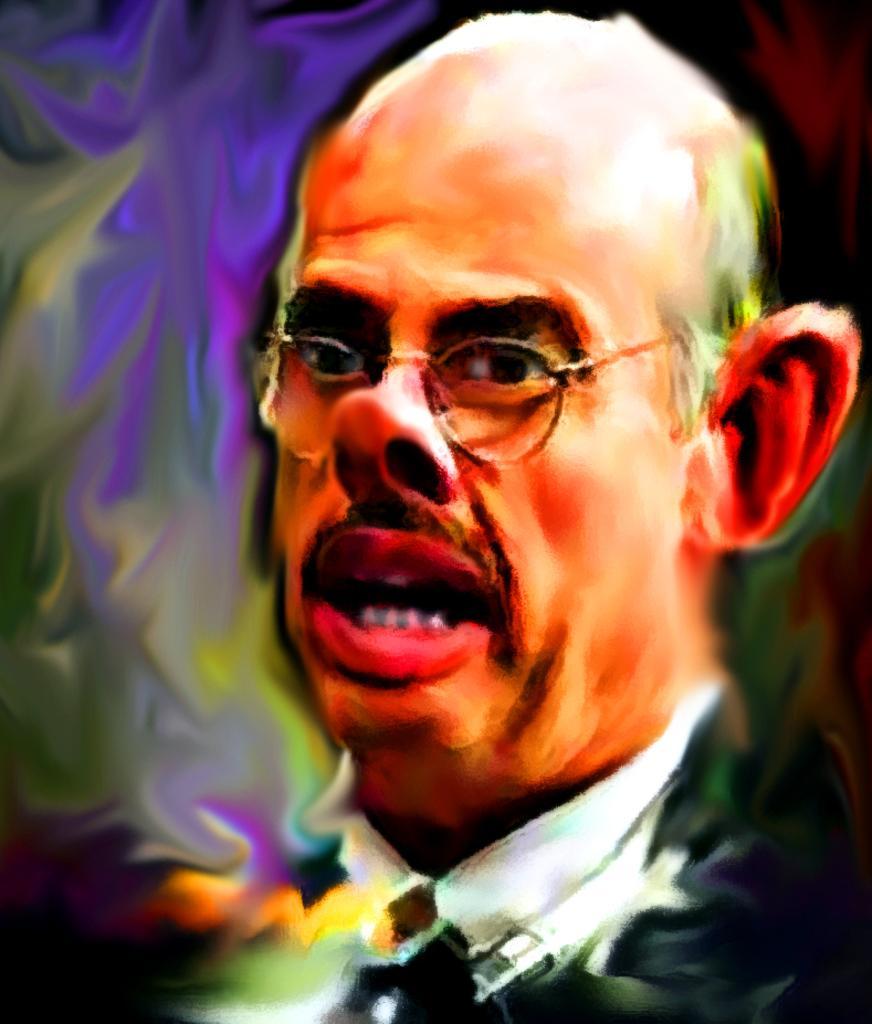How would you summarize this image in a sentence or two? This is a painting. In this picture we can see the head of a man wearing a spectacle. We can see the colorful background. 